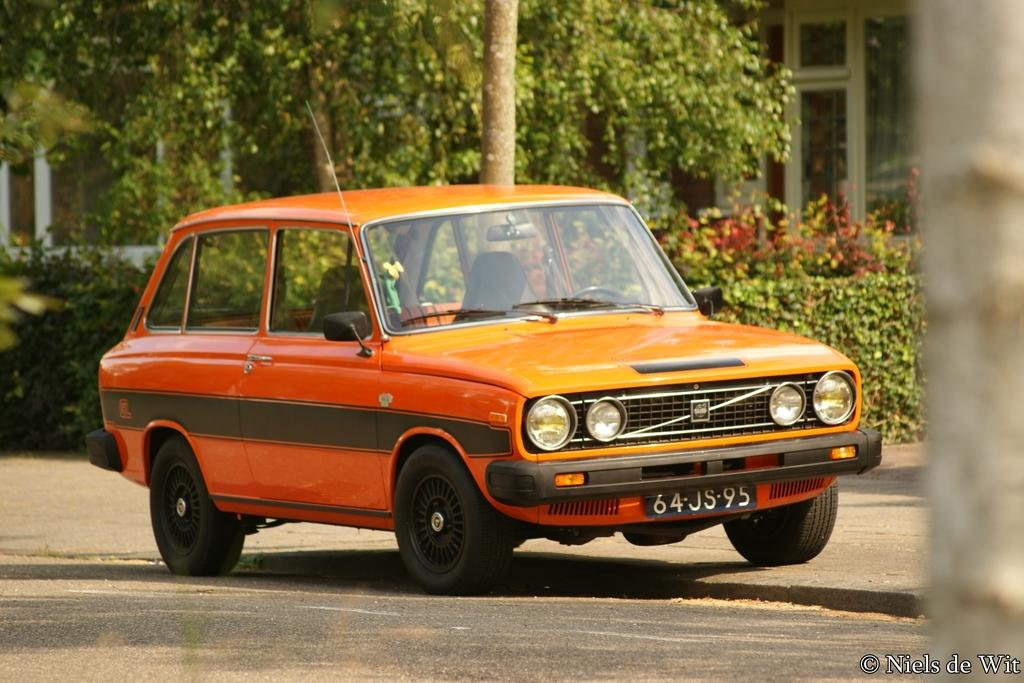What color is the car in the image? The car in the image is orange. Where is the car located in the image? The car is on the road in the image. What type of vegetation can be seen in the image? There are plants and trees in the image. What can be seen in the background of the image? There is a building visible in the background of the image. Where is the cave located in the image? There is no cave present in the image. What type of lighting is used on the stage in the image? There is no stage present in the image. 